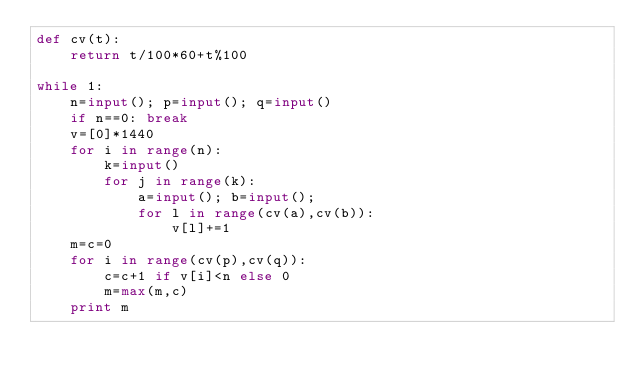<code> <loc_0><loc_0><loc_500><loc_500><_Python_>def cv(t):
	return t/100*60+t%100

while 1:
	n=input(); p=input(); q=input()
	if n==0: break
	v=[0]*1440
	for i in range(n):
		k=input()
		for j in range(k):
			a=input(); b=input();
			for l in range(cv(a),cv(b)):
				v[l]+=1
	m=c=0
	for i in range(cv(p),cv(q)):
		c=c+1 if v[i]<n else 0
		m=max(m,c)
	print m</code> 